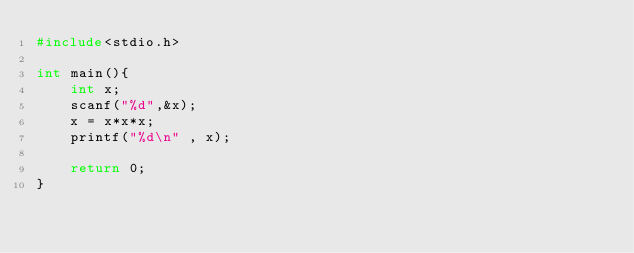<code> <loc_0><loc_0><loc_500><loc_500><_C_>#include<stdio.h>

int main(){
    int x;
	scanf("%d",&x);
	x = x*x*x;
	printf("%d\n" , x);
    
    return 0;
}</code> 